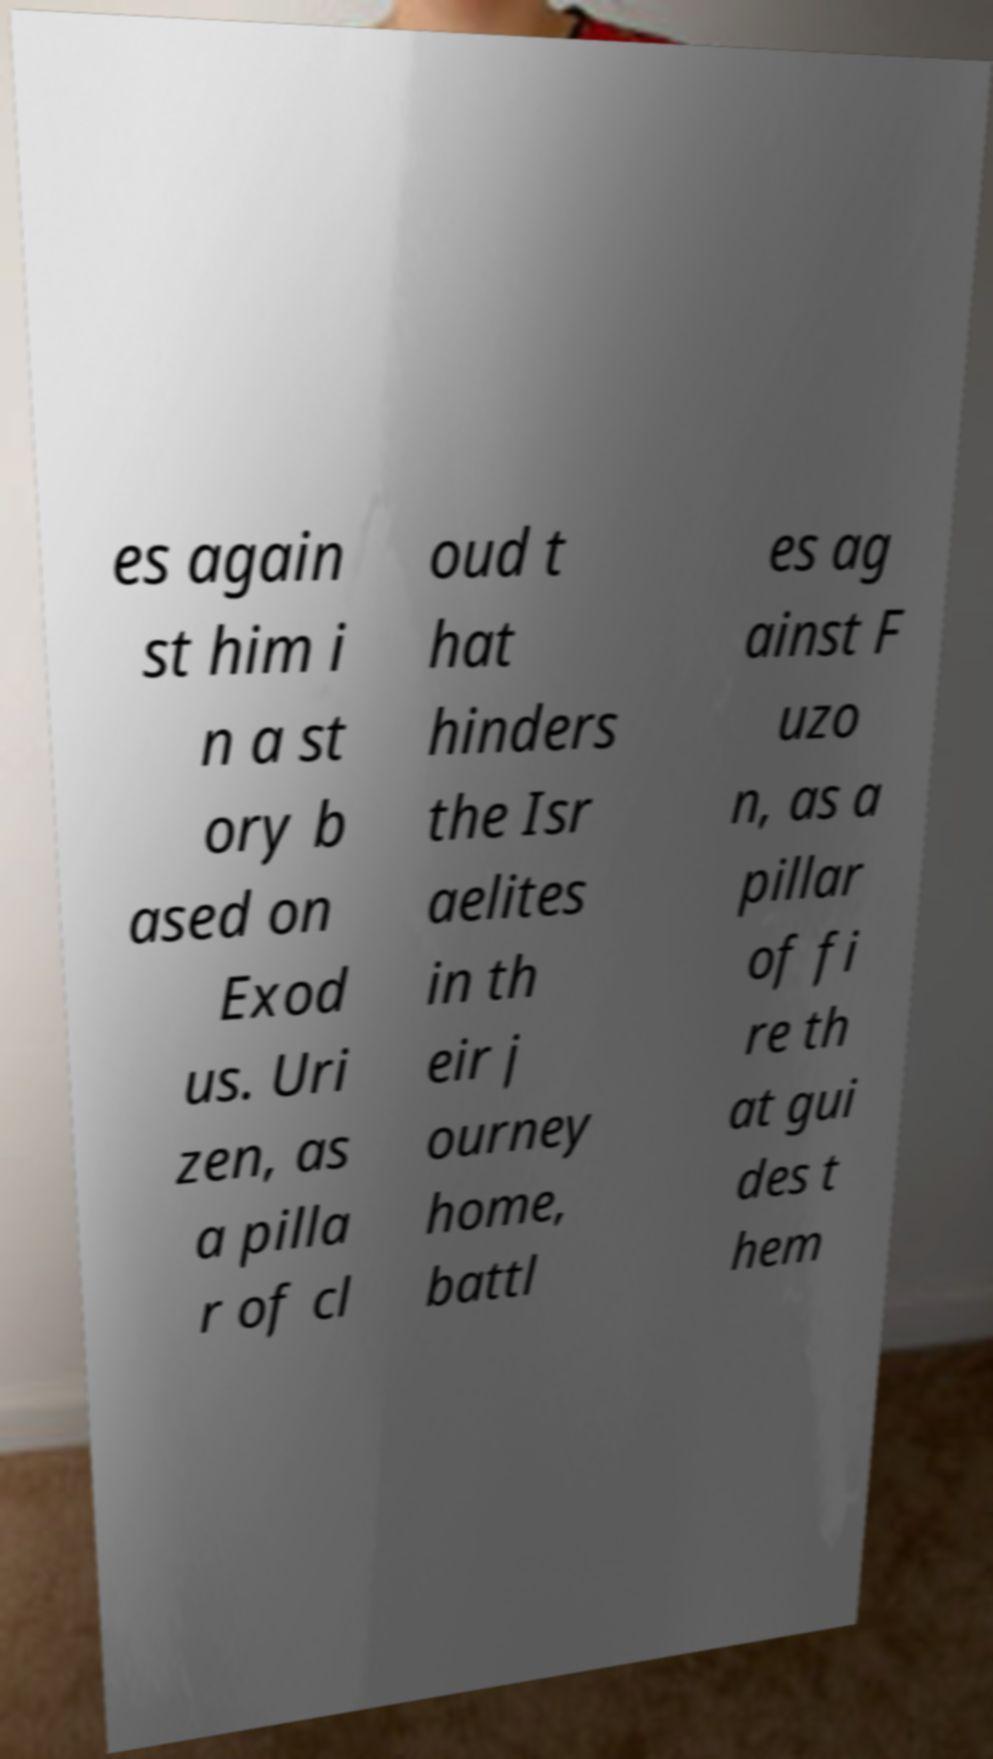What messages or text are displayed in this image? I need them in a readable, typed format. es again st him i n a st ory b ased on Exod us. Uri zen, as a pilla r of cl oud t hat hinders the Isr aelites in th eir j ourney home, battl es ag ainst F uzo n, as a pillar of fi re th at gui des t hem 